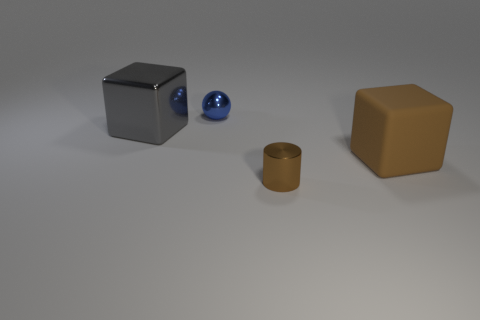Add 2 red metallic spheres. How many objects exist? 6 Add 4 gray shiny blocks. How many gray shiny blocks exist? 5 Subtract 0 red spheres. How many objects are left? 4 Subtract all cylinders. How many objects are left? 3 Subtract all small cyan balls. Subtract all brown cylinders. How many objects are left? 3 Add 3 big gray cubes. How many big gray cubes are left? 4 